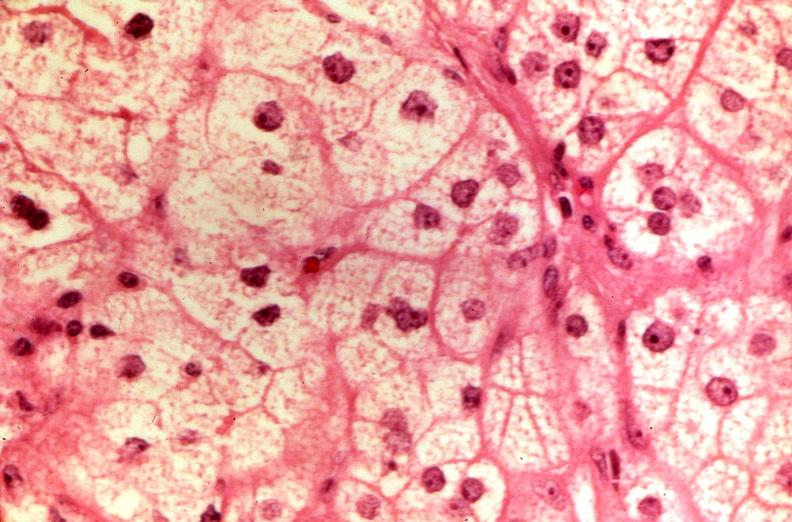s endocrine present?
Answer the question using a single word or phrase. Yes 